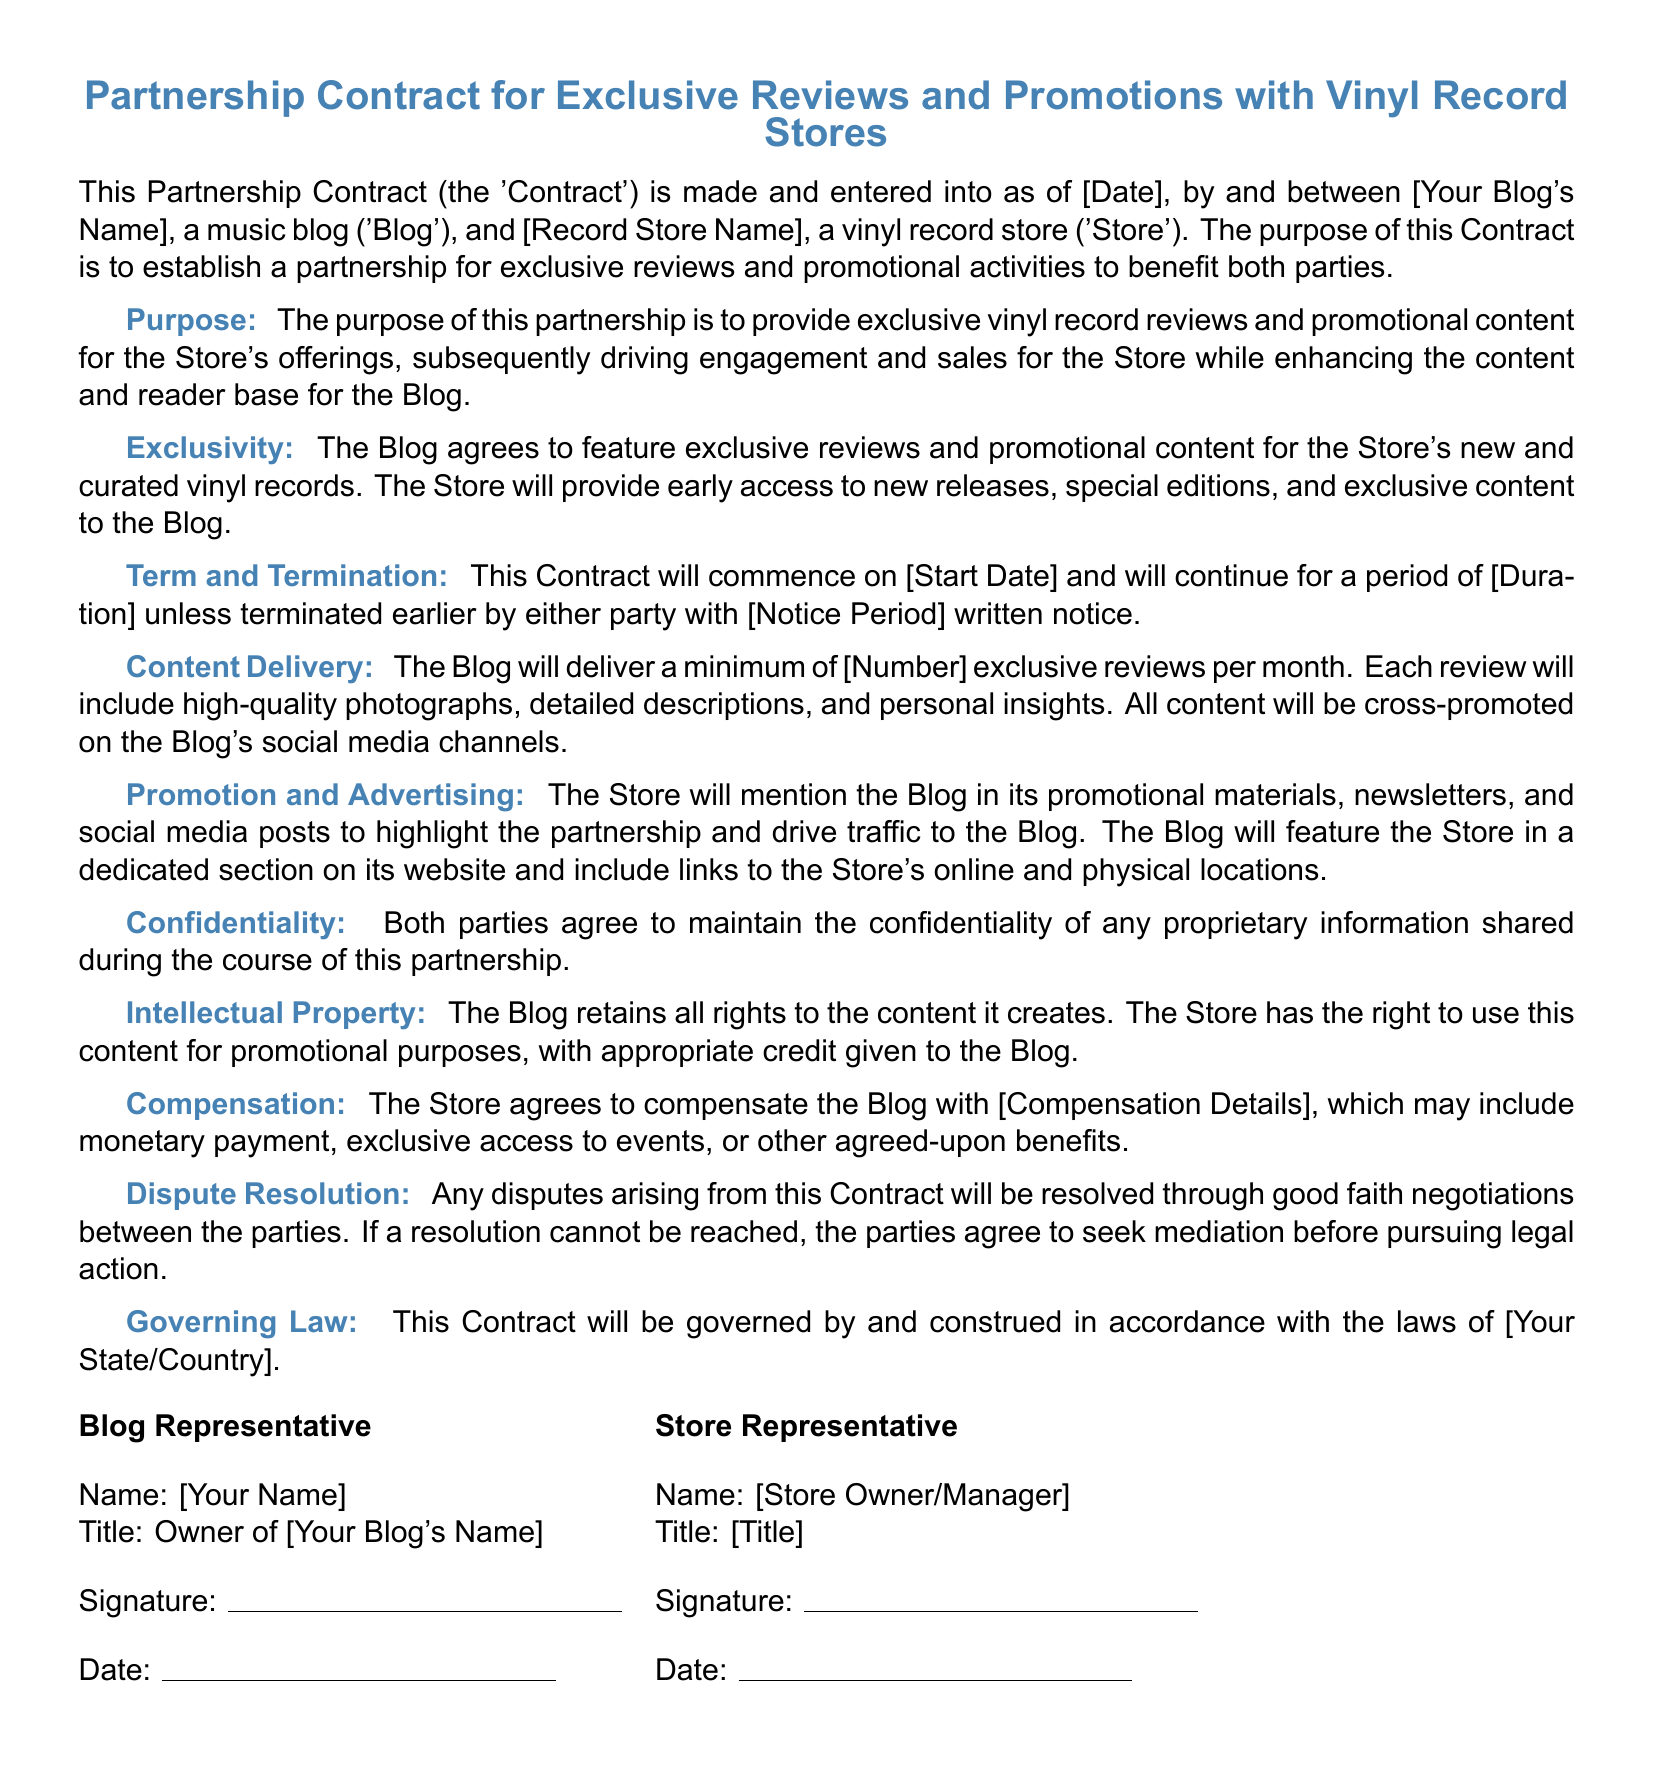What is the purpose of this partnership? The purpose is to provide exclusive vinyl record reviews and promotional content for the Store's offerings.
Answer: exclusive vinyl record reviews and promotional content What is the term of the contract? The term will be stated as [Duration], which is the specified length until termination.
Answer: [Duration] How many exclusive reviews per month is the Blog required to deliver? The document mentions a minimum of [Number] exclusive reviews per month.
Answer: [Number] What must the Store provide to the Blog? The Store will provide early access to new releases, special editions, and exclusive content.
Answer: early access to new releases Which section addresses confidentiality? The section specifically addressing confidentiality is titled 'Confidentiality'.
Answer: Confidentiality What happens if disputes arise from the contract? Disputes will be resolved through good faith negotiations and possibly mediation.
Answer: good faith negotiations Who has rights to the created content? The Blog retains all rights to the content it creates.
Answer: The Blog What is the Blog's name placeholder in the document? The Blog's name placeholder is indicated as [Your Blog's Name].
Answer: [Your Blog's Name] What date does the contract commence? The commencement date is represented as [Start Date].
Answer: [Start Date] What is the governing law for this contract? The governing law is indicated as [Your State/Country].
Answer: [Your State/Country] 